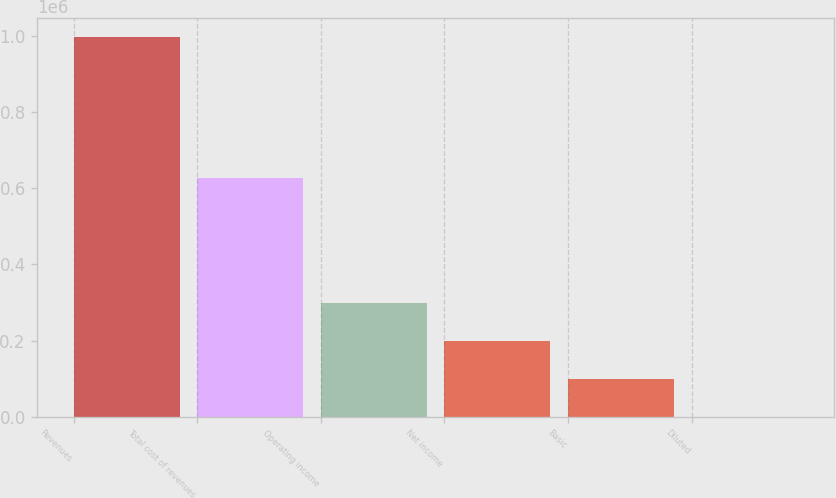Convert chart. <chart><loc_0><loc_0><loc_500><loc_500><bar_chart><fcel>Revenues<fcel>Total cost of revenues<fcel>Operating income<fcel>Net income<fcel>Basic<fcel>Diluted<nl><fcel>996660<fcel>626985<fcel>298998<fcel>199333<fcel>99666.6<fcel>0.71<nl></chart> 